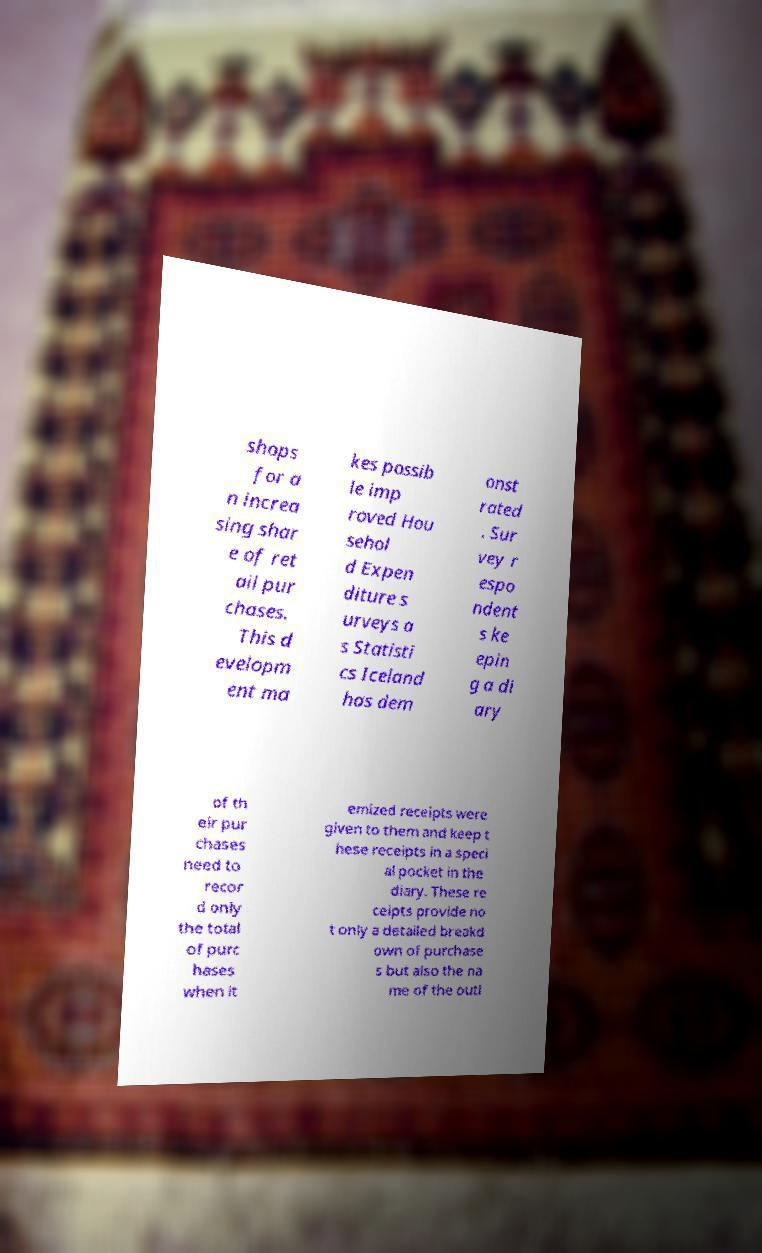What messages or text are displayed in this image? I need them in a readable, typed format. shops for a n increa sing shar e of ret ail pur chases. This d evelopm ent ma kes possib le imp roved Hou sehol d Expen diture s urveys a s Statisti cs Iceland has dem onst rated . Sur vey r espo ndent s ke epin g a di ary of th eir pur chases need to recor d only the total of purc hases when it emized receipts were given to them and keep t hese receipts in a speci al pocket in the diary. These re ceipts provide no t only a detailed breakd own of purchase s but also the na me of the outl 